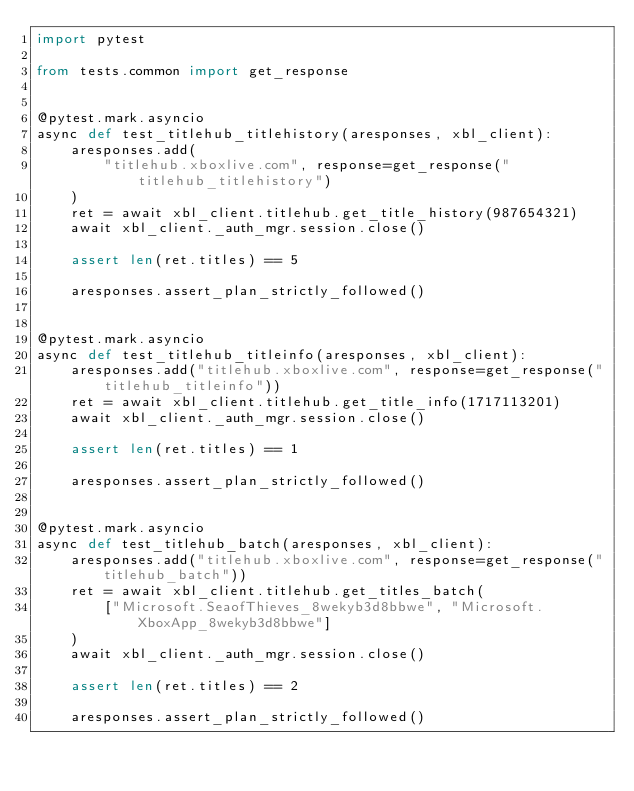<code> <loc_0><loc_0><loc_500><loc_500><_Python_>import pytest

from tests.common import get_response


@pytest.mark.asyncio
async def test_titlehub_titlehistory(aresponses, xbl_client):
    aresponses.add(
        "titlehub.xboxlive.com", response=get_response("titlehub_titlehistory")
    )
    ret = await xbl_client.titlehub.get_title_history(987654321)
    await xbl_client._auth_mgr.session.close()

    assert len(ret.titles) == 5

    aresponses.assert_plan_strictly_followed()


@pytest.mark.asyncio
async def test_titlehub_titleinfo(aresponses, xbl_client):
    aresponses.add("titlehub.xboxlive.com", response=get_response("titlehub_titleinfo"))
    ret = await xbl_client.titlehub.get_title_info(1717113201)
    await xbl_client._auth_mgr.session.close()

    assert len(ret.titles) == 1

    aresponses.assert_plan_strictly_followed()


@pytest.mark.asyncio
async def test_titlehub_batch(aresponses, xbl_client):
    aresponses.add("titlehub.xboxlive.com", response=get_response("titlehub_batch"))
    ret = await xbl_client.titlehub.get_titles_batch(
        ["Microsoft.SeaofThieves_8wekyb3d8bbwe", "Microsoft.XboxApp_8wekyb3d8bbwe"]
    )
    await xbl_client._auth_mgr.session.close()

    assert len(ret.titles) == 2

    aresponses.assert_plan_strictly_followed()
</code> 